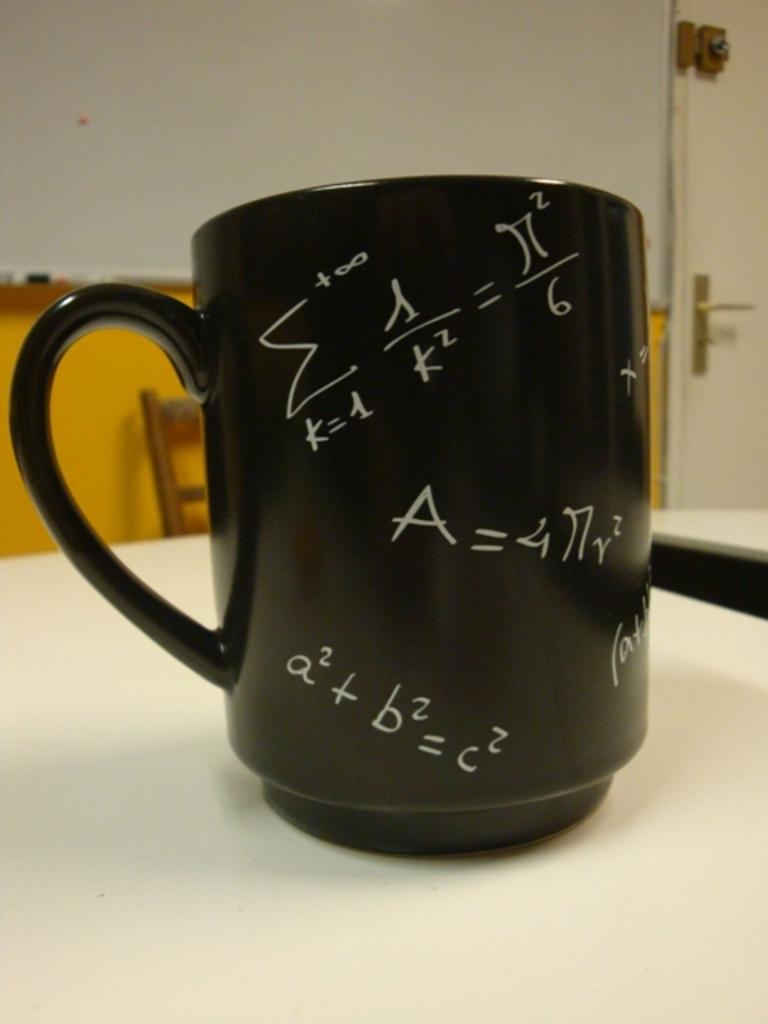<image>
Summarize the visual content of the image. a cup that has the Pythagorean Theorem on it 